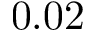<formula> <loc_0><loc_0><loc_500><loc_500>0 . 0 2</formula> 